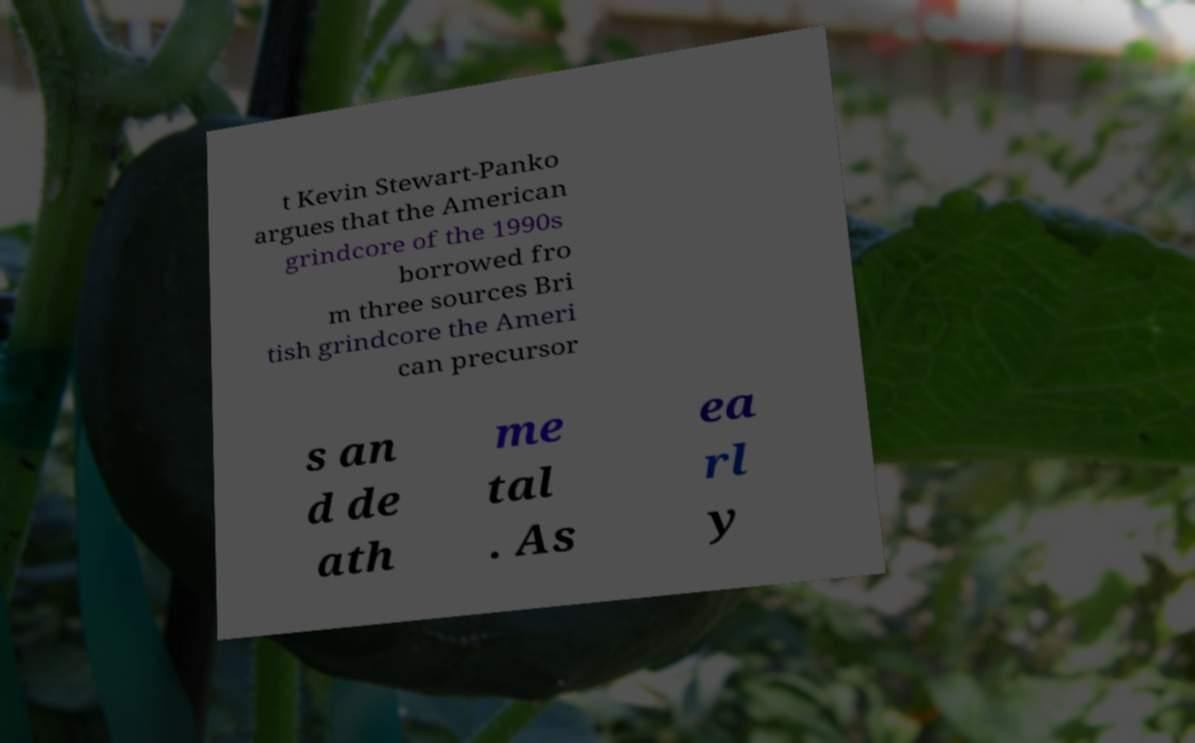There's text embedded in this image that I need extracted. Can you transcribe it verbatim? t Kevin Stewart-Panko argues that the American grindcore of the 1990s borrowed fro m three sources Bri tish grindcore the Ameri can precursor s an d de ath me tal . As ea rl y 